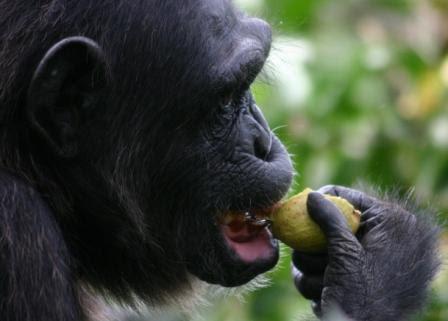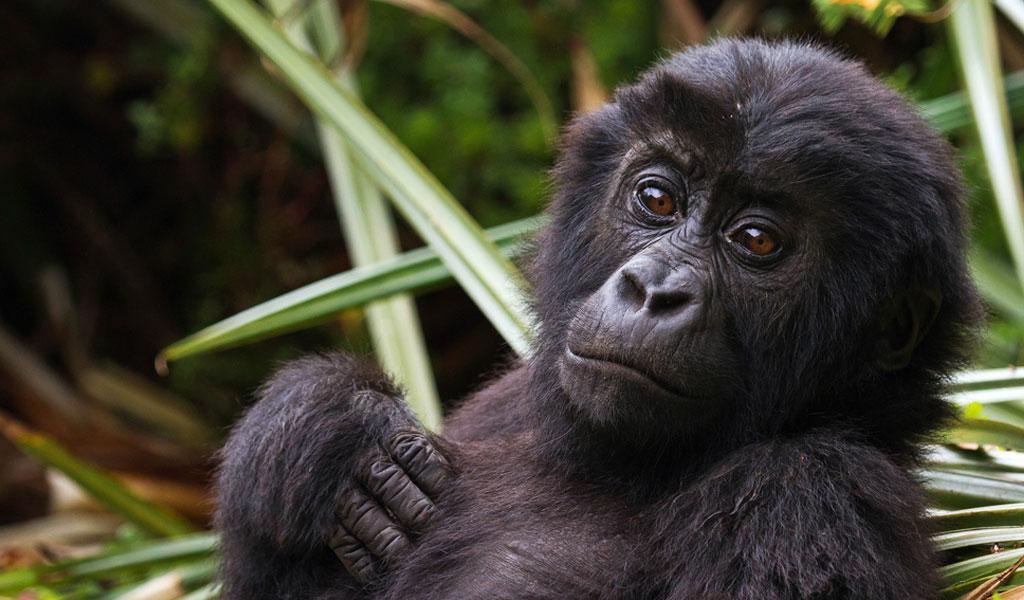The first image is the image on the left, the second image is the image on the right. For the images shown, is this caption "Each image shows a gorilla grasping edible plant material, and at least one image shows a gorilla chewing on the item." true? Answer yes or no. No. The first image is the image on the left, the second image is the image on the right. Evaluate the accuracy of this statement regarding the images: "Only the image on the right depicts a gorilla holding food up to its mouth.". Is it true? Answer yes or no. No. 